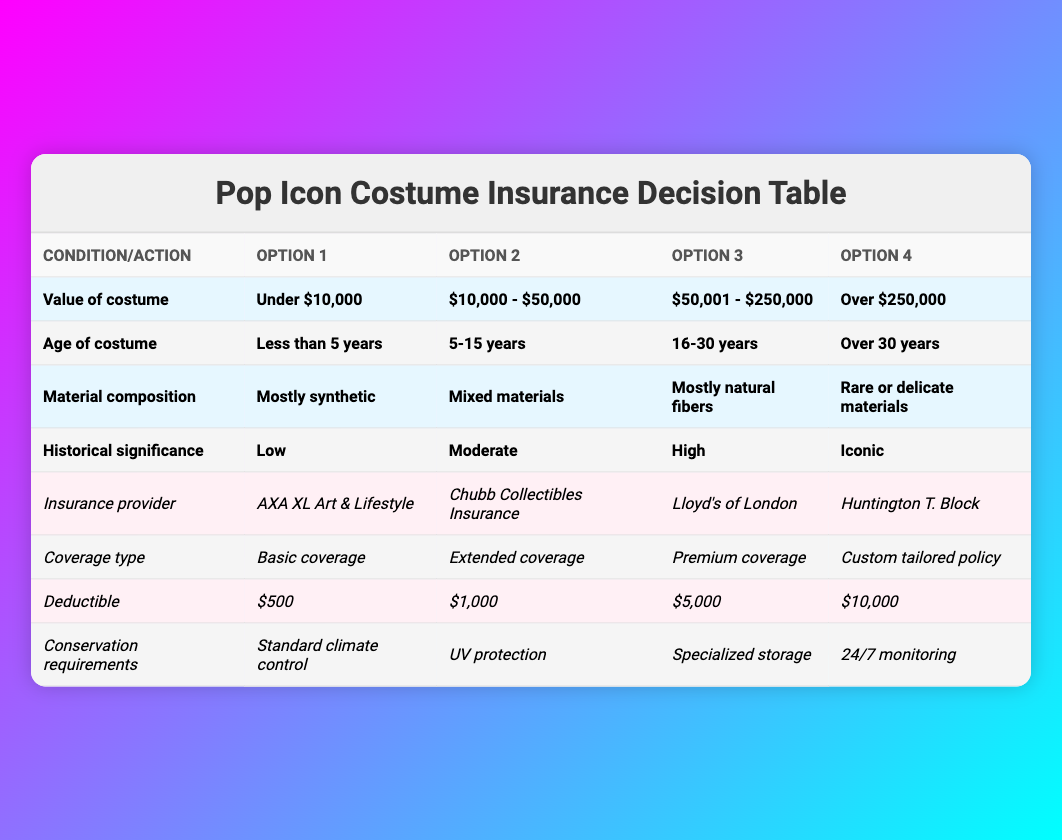What insurance provider is recommended for costumes valued over $250,000? The table specifies "Lloyd's of London" as the insurance provider for costumes in the highest value category, which is "Over $250,000."
Answer: Lloyd's of London For a costume aged between 5 to 15 years with high historical significance, which coverage type should be considered? The coverage type column shows "Extended coverage" is suggested for historical significance categorized as "High," meaning that this specific combination would likely warrant more comprehensive coverage.
Answer: Extended coverage True or False: A costume with mostly synthetic materials can have a deductible of $10,000. The deductible options are independent of the material composition. Since $10,000 is listed in the deductible options, it is valid for any costume regardless of its material. Therefore, the statement is true.
Answer: True What are the conservation requirements for costumes made of rare or delicate materials? The table indicates that the conservation requirement for rare or delicate materials should be "24/7 monitoring," which is the highest level of care specified for such items.
Answer: 24/7 monitoring Calculate the total number of insurance providers listed in the table. There are four insurance provider options: AXA XL Art & Lifestyle, Chubb Collectibles Insurance, Lloyd's of London, and Huntington T. Block, leading to a total of 4 providers.
Answer: 4 For a costume valued at $10,000 - $50,000, which deductible options are available? The table shows four deductible options: $500, $1,000, $5,000, and $10,000. All options are available regardless of the costume's value range.
Answer: All options available If a costume is over 30 years old and made of mixed materials, which insurance provider is generally recommended? The table does not specify providers based on age or material combination, so any of the providers could be applicable. However, typically, "Chubb Collectibles Insurance" is known for older items.
Answer: Chubb Collectibles Insurance (common recommendation) What is the difference in conservation requirements between costumes with mostly synthetic materials and those with rare or delicate materials? The conservation requirement for mostly synthetic materials is "Standard climate control," while for rare or delicate materials, it is "24/7 monitoring." The difference lies in the level of monitoring and care required for protection.
Answer: 24/7 monitoring vs. Standard climate control True or False: Costumes with low historical significance can be insured under a custom tailored policy. The table does not restrict insurance policies based on historical significance; hence, it is possible to have a custom tailored policy for any historical significance level, including low. Therefore, the statement is true.
Answer: True 